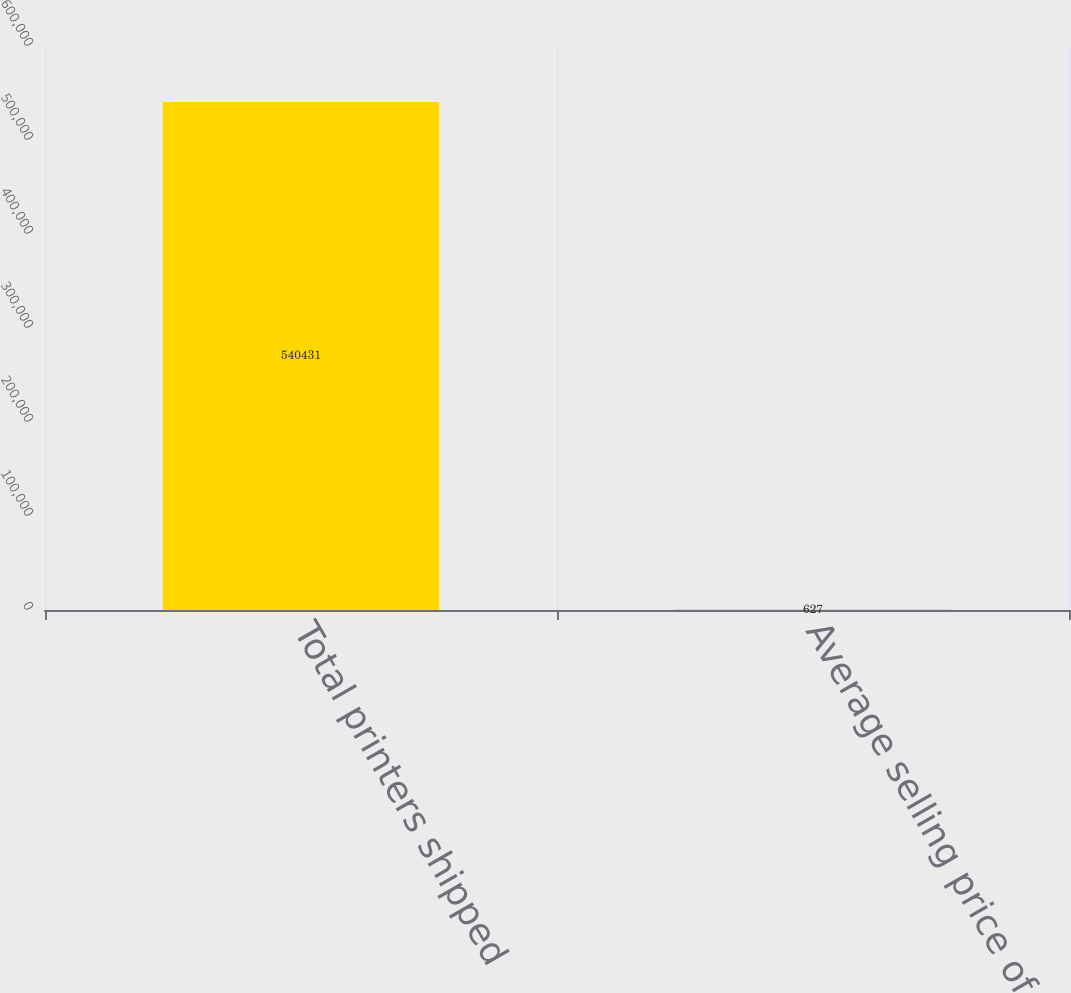Convert chart to OTSL. <chart><loc_0><loc_0><loc_500><loc_500><bar_chart><fcel>Total printers shipped<fcel>Average selling price of<nl><fcel>540431<fcel>627<nl></chart> 